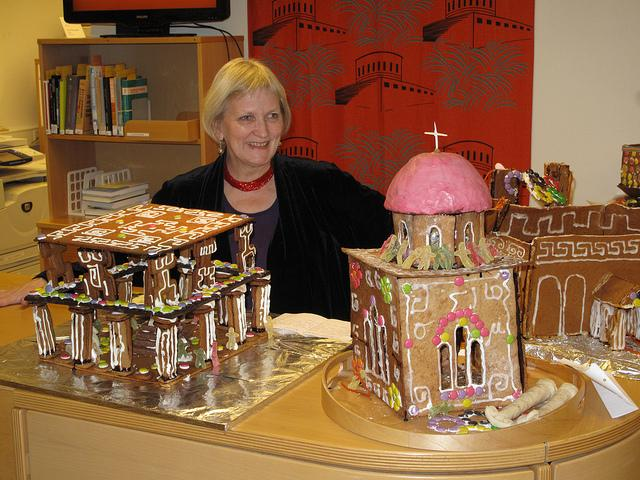What are these buildings mostly made of?

Choices:
A) plastic
B) gingerbread
C) fiberglass
D) gingersnap gingerbread 